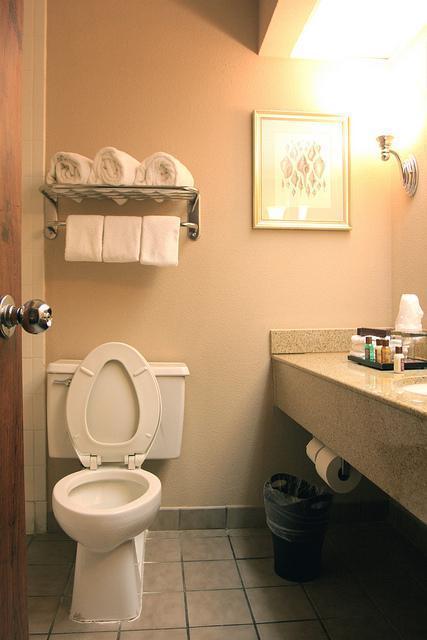How many rolls of toilet paper are there?
Give a very brief answer. 2. How many toilets are visible?
Give a very brief answer. 1. 